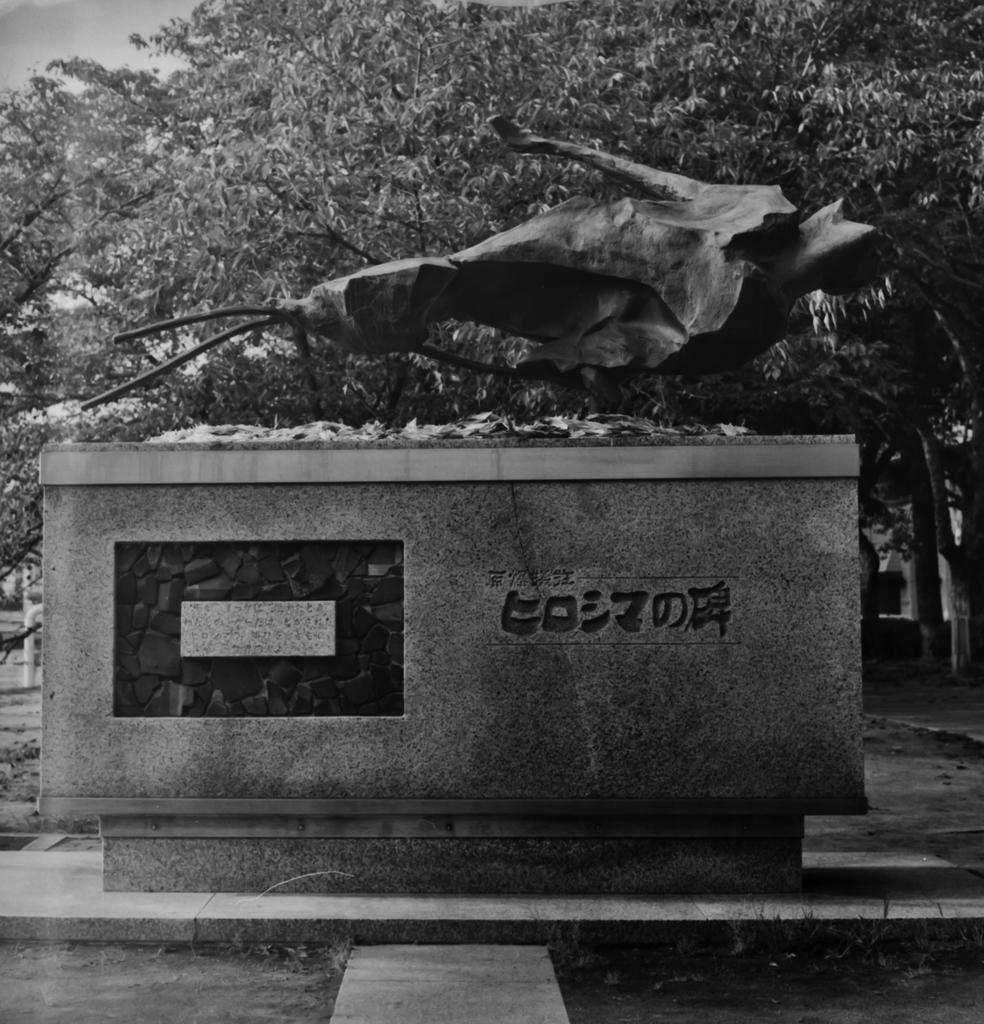Please provide a concise description of this image. This is a black and white image. This looks like a sculpture. I think this is the pillar with the name on it. I can see the trees with branches and leaves. 